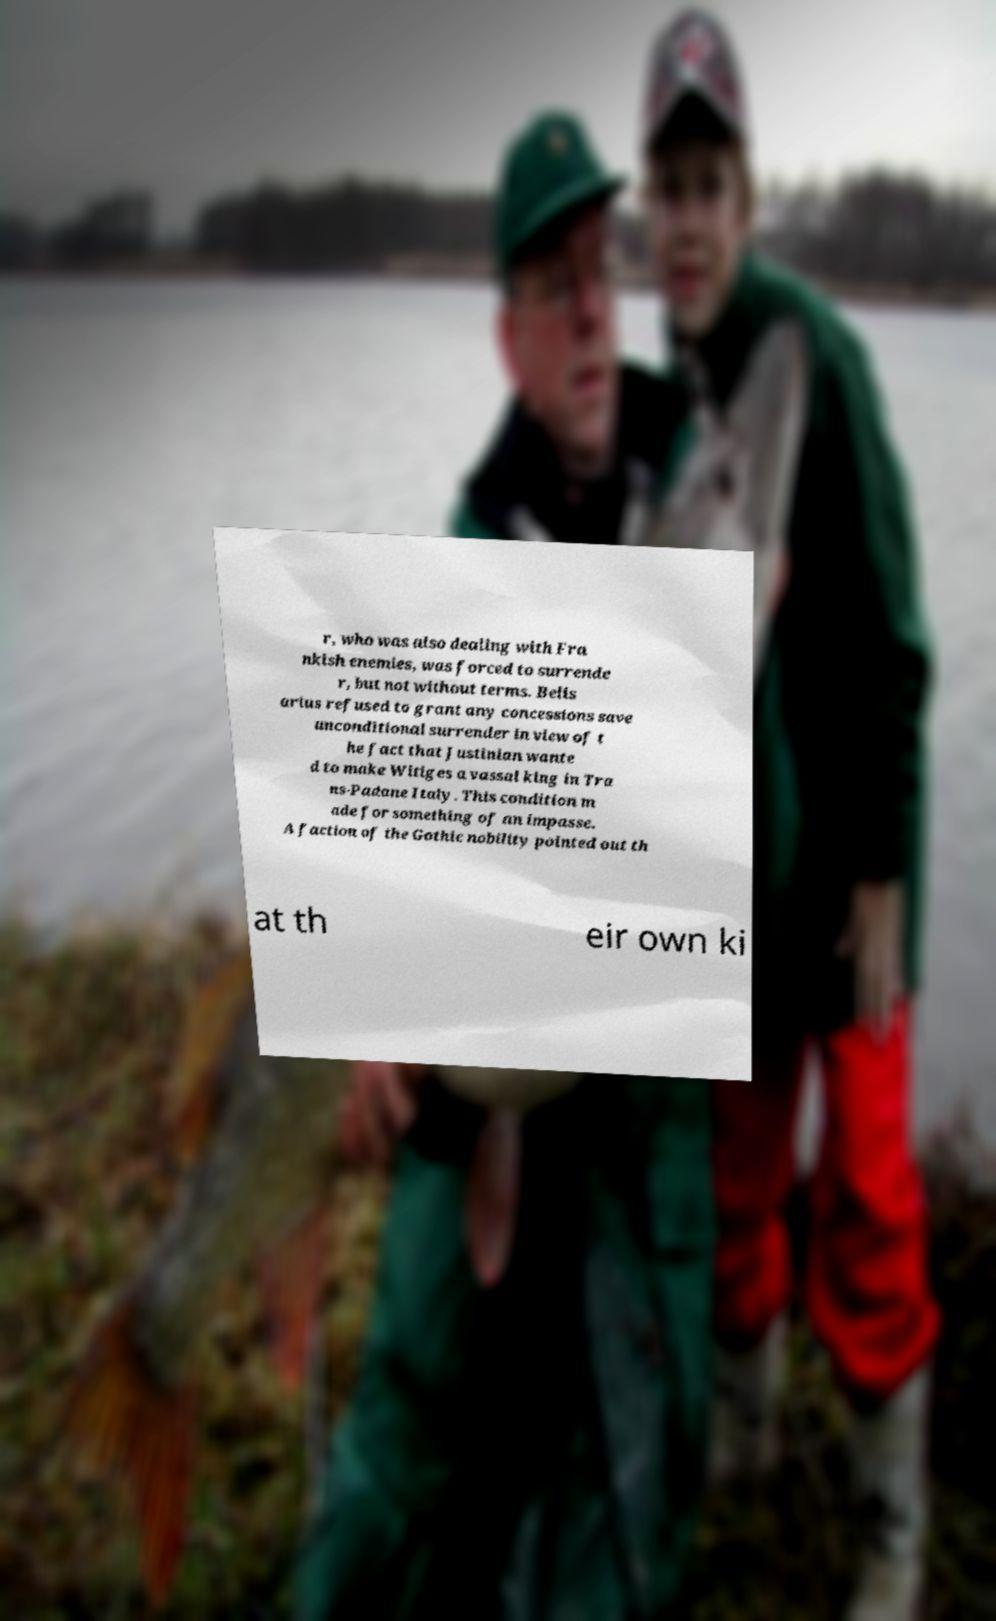Can you accurately transcribe the text from the provided image for me? r, who was also dealing with Fra nkish enemies, was forced to surrende r, but not without terms. Belis arius refused to grant any concessions save unconditional surrender in view of t he fact that Justinian wante d to make Witiges a vassal king in Tra ns-Padane Italy. This condition m ade for something of an impasse. A faction of the Gothic nobility pointed out th at th eir own ki 